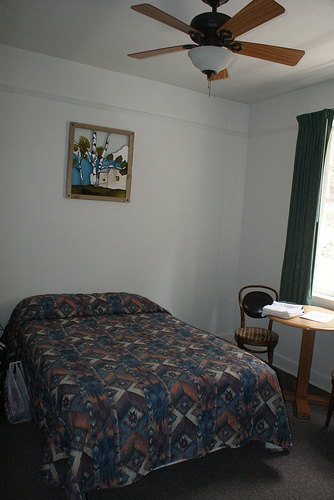<image>
Can you confirm if the ceiling fan is on the ceiling? Yes. Looking at the image, I can see the ceiling fan is positioned on top of the ceiling, with the ceiling providing support. Where is the ceiling fan in relation to the bed? Is it above the bed? Yes. The ceiling fan is positioned above the bed in the vertical space, higher up in the scene. 